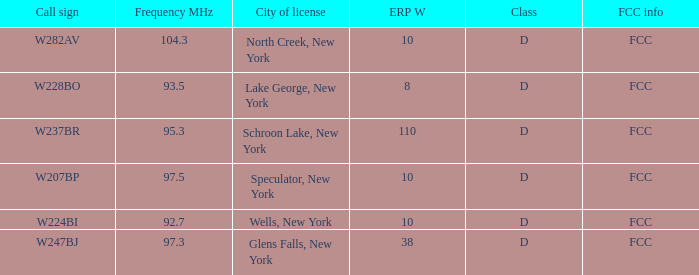Name the ERP W for glens falls, new york 38.0. 